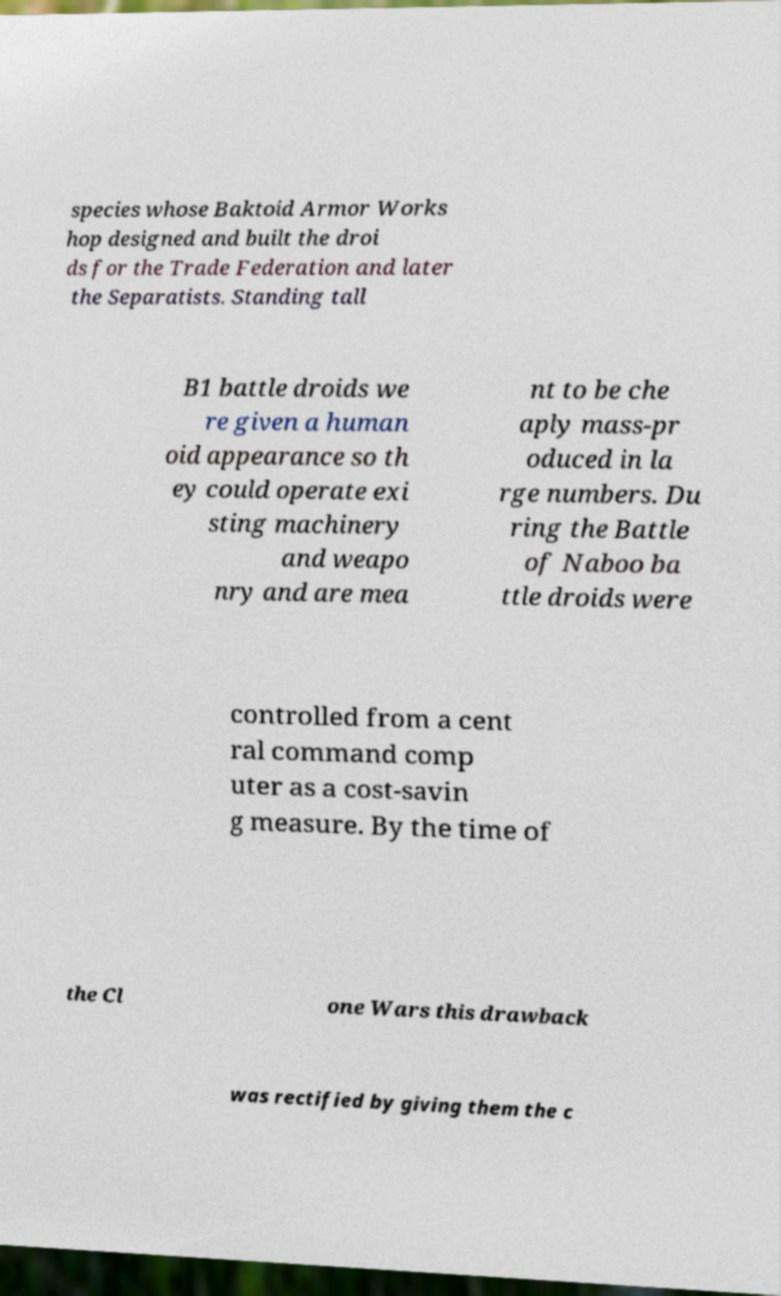Could you assist in decoding the text presented in this image and type it out clearly? species whose Baktoid Armor Works hop designed and built the droi ds for the Trade Federation and later the Separatists. Standing tall B1 battle droids we re given a human oid appearance so th ey could operate exi sting machinery and weapo nry and are mea nt to be che aply mass-pr oduced in la rge numbers. Du ring the Battle of Naboo ba ttle droids were controlled from a cent ral command comp uter as a cost-savin g measure. By the time of the Cl one Wars this drawback was rectified by giving them the c 